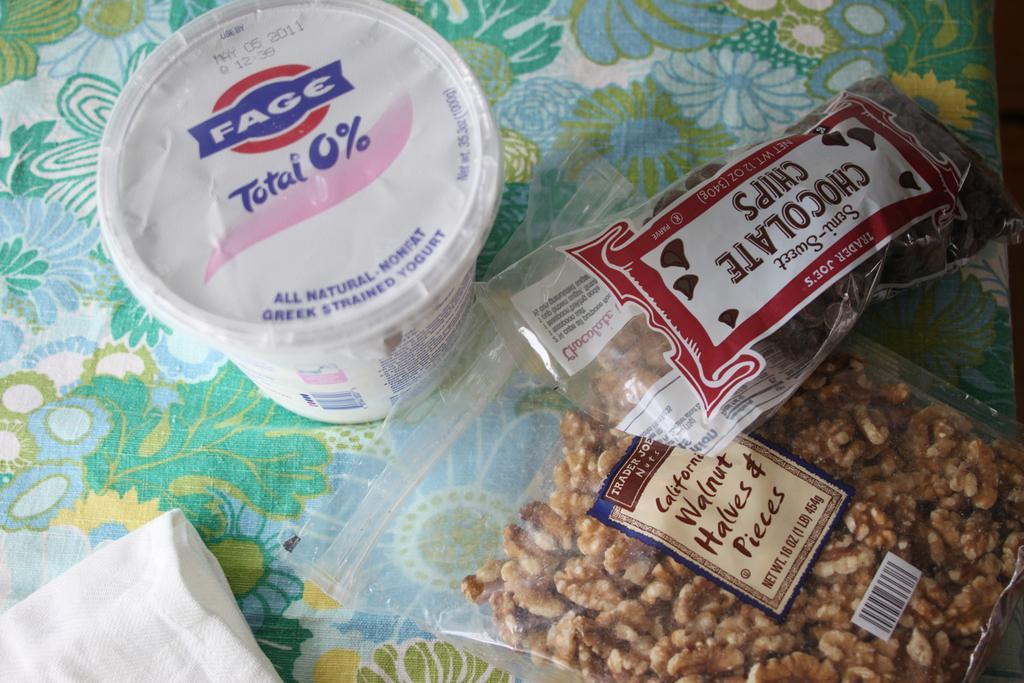In one or two sentences, can you explain what this image depicts? In this image we can see one chocolate packet, one walnut packet, tissue and one yogurt box. 